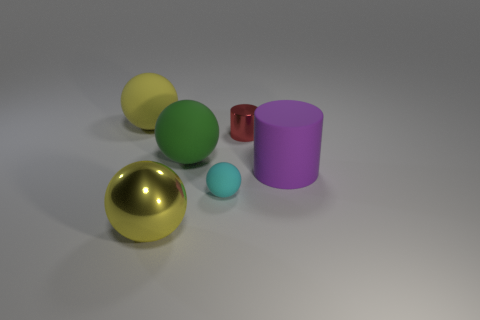What is the shape of the purple object that is the same size as the metallic sphere?
Make the answer very short. Cylinder. What number of other objects are the same color as the rubber cylinder?
Your answer should be very brief. 0. How many cyan things are either tiny spheres or tiny shiny cubes?
Offer a very short reply. 1. There is a large rubber object that is on the right side of the green ball; is it the same shape as the yellow object in front of the green thing?
Make the answer very short. No. How many other things are the same material as the big green ball?
Your answer should be compact. 3. There is a big yellow object in front of the yellow thing behind the small cyan ball; is there a tiny red thing left of it?
Offer a very short reply. No. Do the small sphere and the tiny red cylinder have the same material?
Offer a very short reply. No. Is there any other thing that has the same shape as the purple matte thing?
Keep it short and to the point. Yes. What material is the sphere to the left of the large yellow object that is right of the large yellow matte thing made of?
Your answer should be compact. Rubber. There is a metal object behind the small cyan thing; what is its size?
Make the answer very short. Small. 